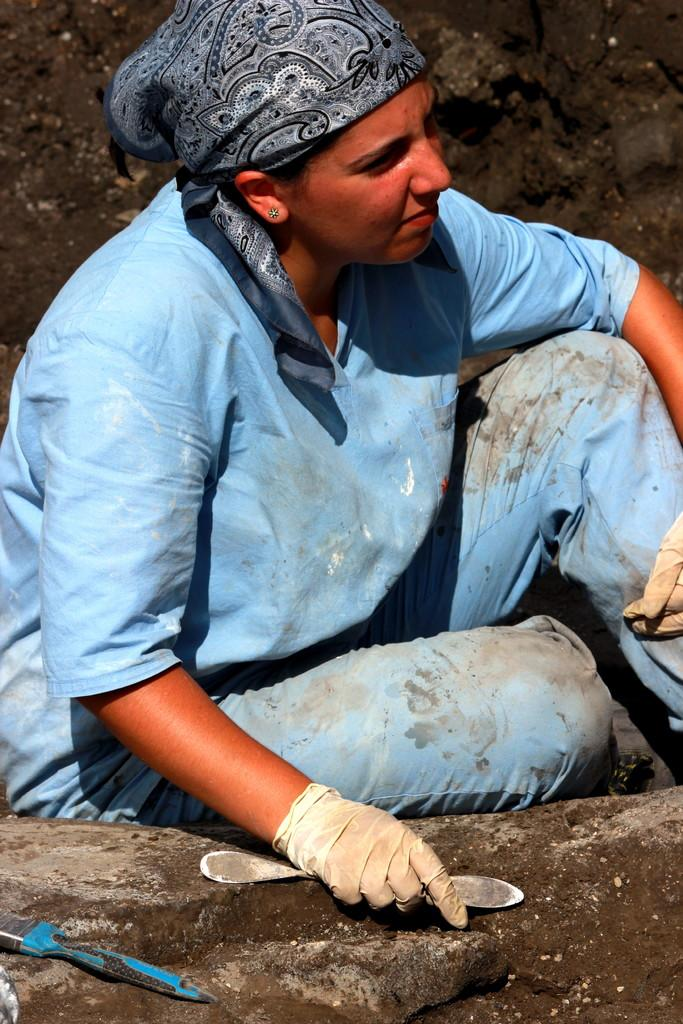Who is present in the image? There is a person in the image. What is the person wearing? The person is wearing a blue dress. What is the person's position in the image? The person is sitting on the ground. What is the person holding in the image? The person is holding an object. What can be seen on the ground in the image? There is an object on the ground. Is there a pancake floating in the sky in the image? No, there is no pancake visible in the image, and the sky is not mentioned in the provided facts. 